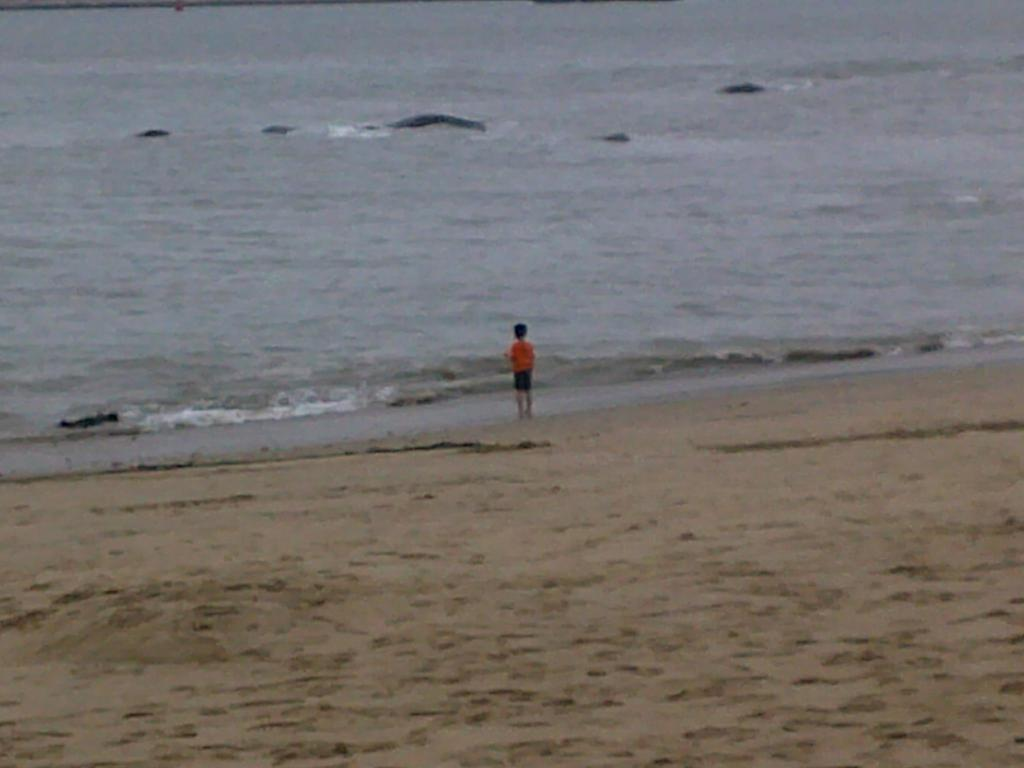Who is the main subject in the image? There is a child in the image. Where is the child located? The child is standing on the seashore. What can be seen in the background of the image? There is a river in the background of the image. What type of beetle can be seen crawling on the child's shoulder in the image? There is no beetle present on the child's shoulder in the image. 